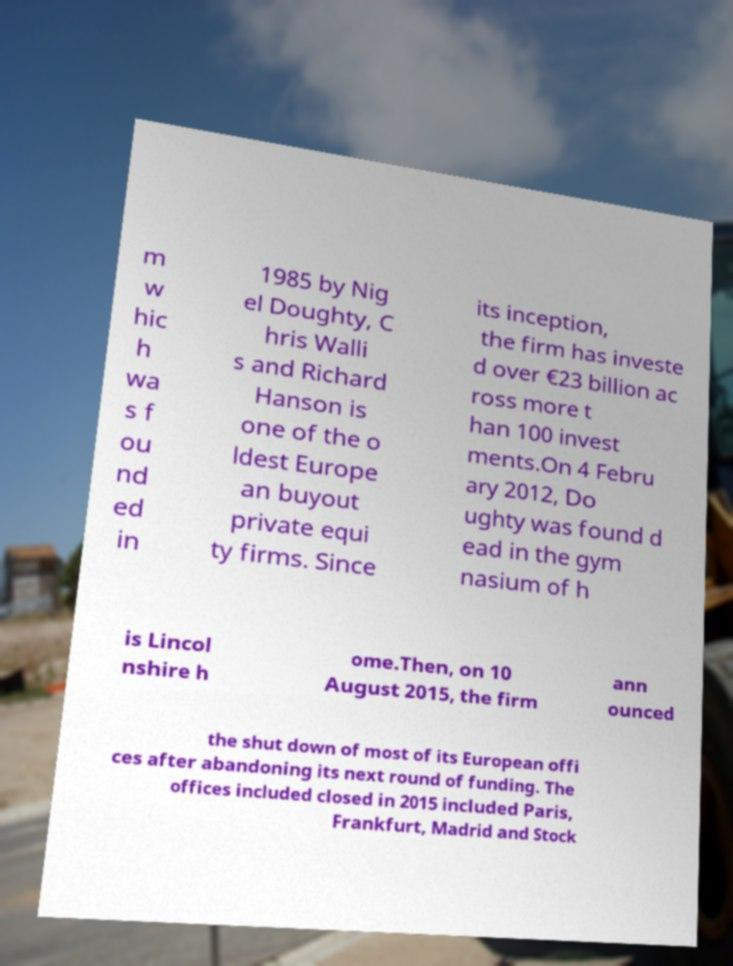Can you read and provide the text displayed in the image?This photo seems to have some interesting text. Can you extract and type it out for me? m w hic h wa s f ou nd ed in 1985 by Nig el Doughty, C hris Walli s and Richard Hanson is one of the o ldest Europe an buyout private equi ty firms. Since its inception, the firm has investe d over €23 billion ac ross more t han 100 invest ments.On 4 Febru ary 2012, Do ughty was found d ead in the gym nasium of h is Lincol nshire h ome.Then, on 10 August 2015, the firm ann ounced the shut down of most of its European offi ces after abandoning its next round of funding. The offices included closed in 2015 included Paris, Frankfurt, Madrid and Stock 